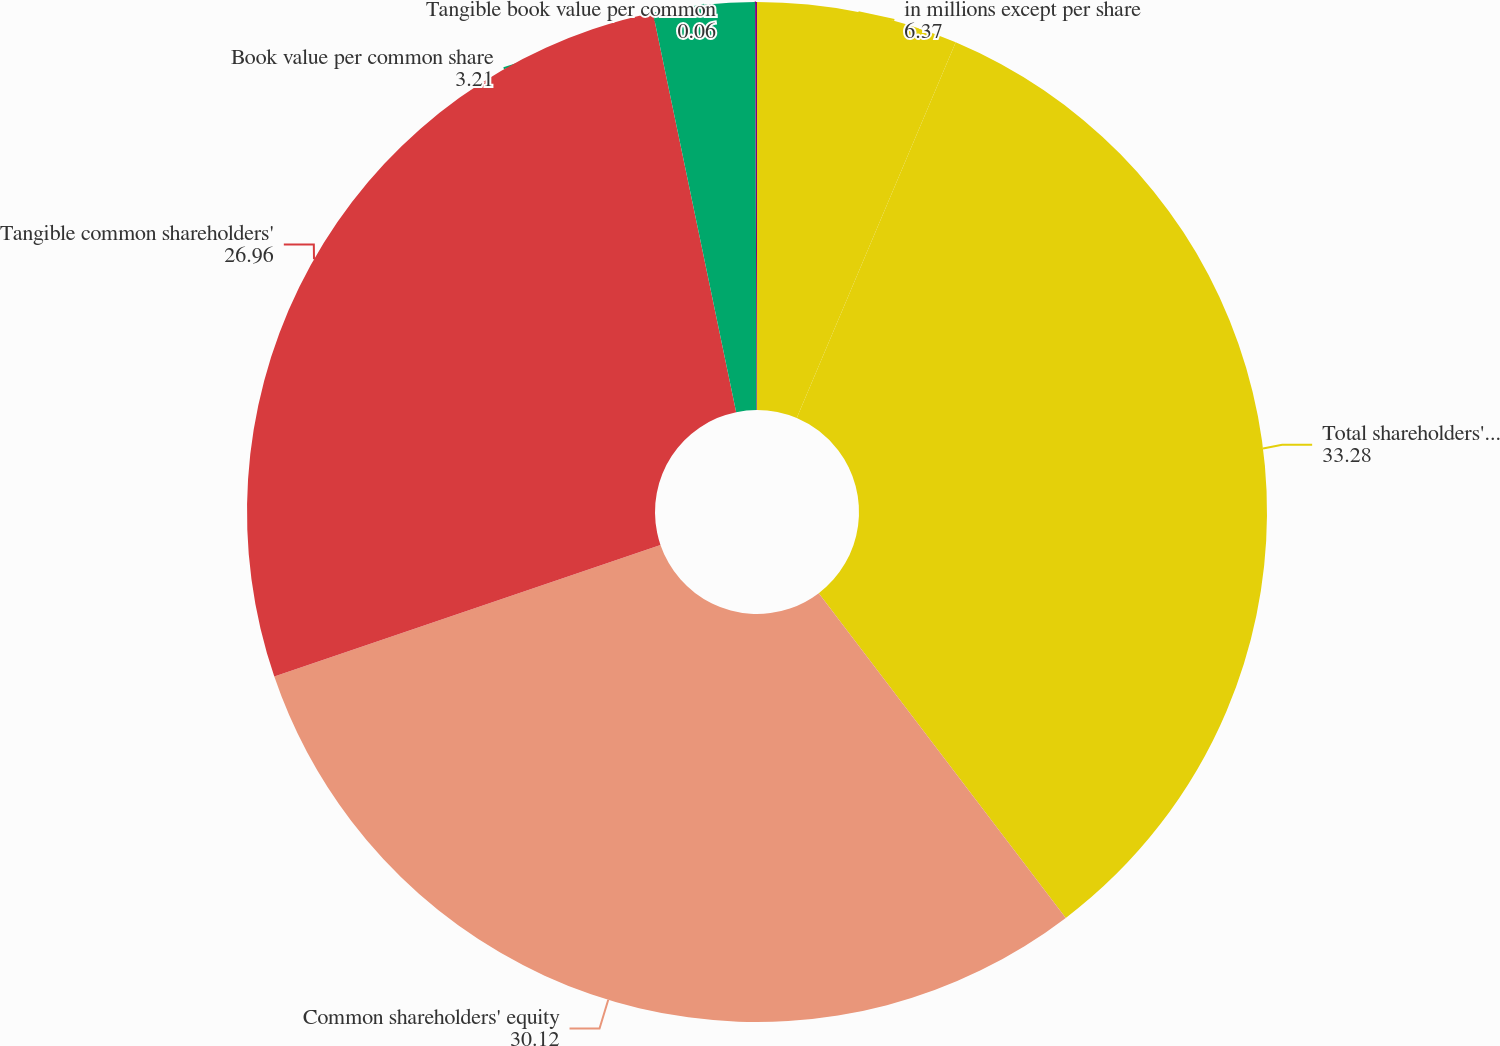<chart> <loc_0><loc_0><loc_500><loc_500><pie_chart><fcel>in millions except per share<fcel>Total shareholders' equity<fcel>Common shareholders' equity<fcel>Tangible common shareholders'<fcel>Book value per common share<fcel>Tangible book value per common<nl><fcel>6.37%<fcel>33.28%<fcel>30.12%<fcel>26.96%<fcel>3.21%<fcel>0.06%<nl></chart> 